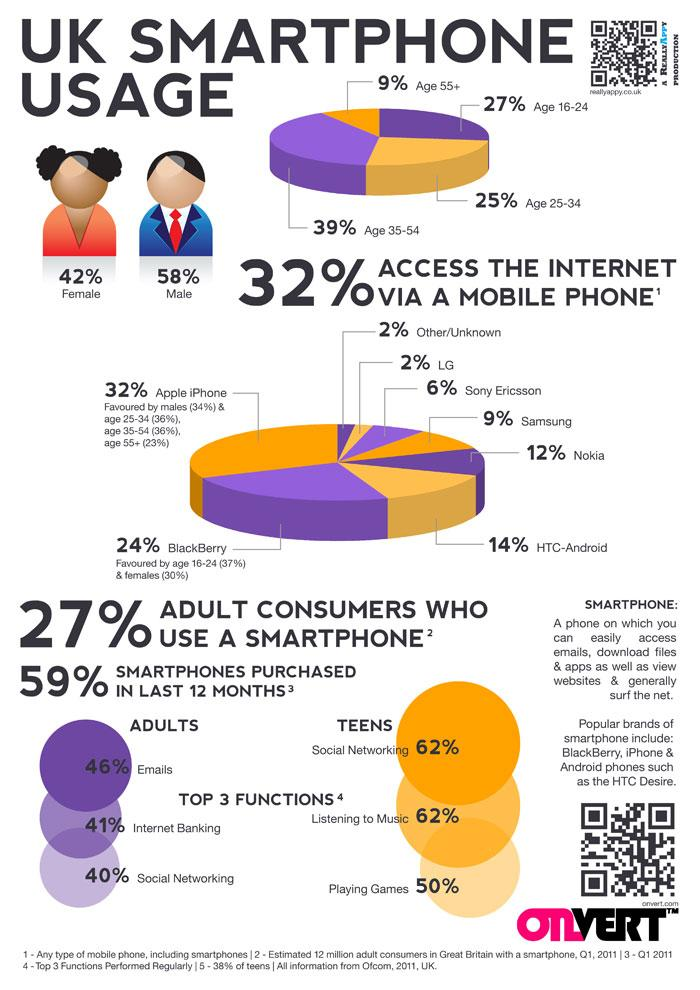List a handful of essential elements in this visual. Approximately 23% of senior citizens use Apple iPhones, according to recent data. Among adults and teens, teens are the most likely to engage in social networking. According to a recent survey, 27% of people use Nokia, Samsung, and Sony Ericsson as their preferred mobile phone brands. It is generally believed that men use smartphones more than women. Approximately 9% of senior citizens in the UK use smartphones, according to a recent survey. 